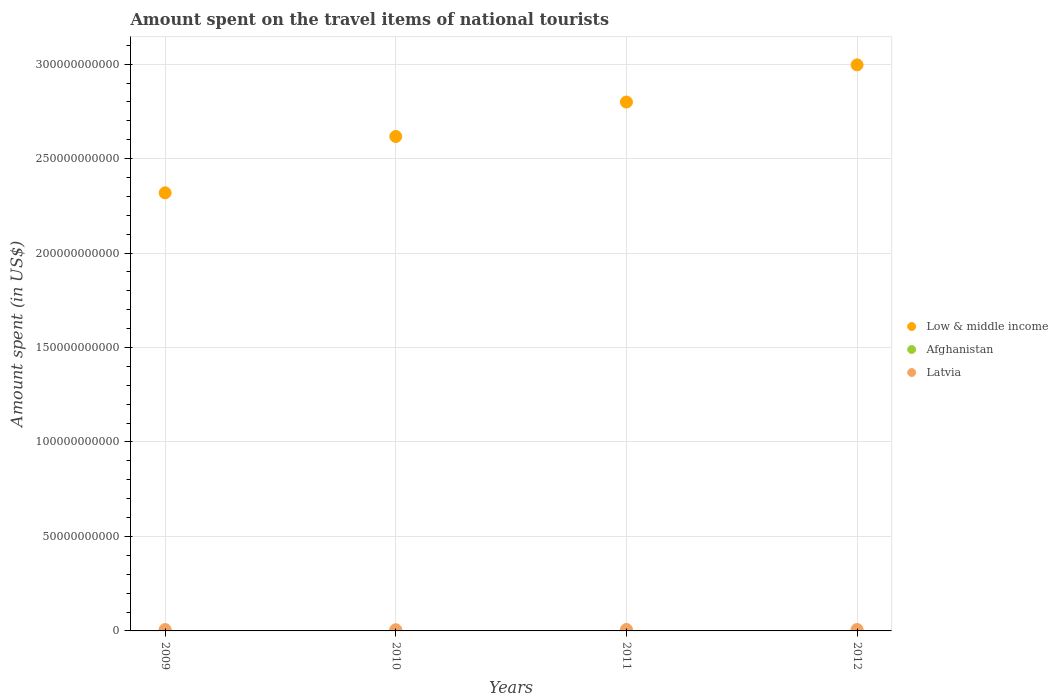Is the number of dotlines equal to the number of legend labels?
Provide a succinct answer. Yes. What is the amount spent on the travel items of national tourists in Low & middle income in 2009?
Your answer should be compact. 2.32e+11. Across all years, what is the maximum amount spent on the travel items of national tourists in Afghanistan?
Offer a terse response. 7.10e+07. Across all years, what is the minimum amount spent on the travel items of national tourists in Afghanistan?
Your answer should be very brief. 3.90e+07. In which year was the amount spent on the travel items of national tourists in Afghanistan maximum?
Make the answer very short. 2011. In which year was the amount spent on the travel items of national tourists in Low & middle income minimum?
Make the answer very short. 2009. What is the total amount spent on the travel items of national tourists in Latvia in the graph?
Ensure brevity in your answer.  2.88e+09. What is the difference between the amount spent on the travel items of national tourists in Afghanistan in 2009 and that in 2010?
Give a very brief answer. -1.60e+07. What is the difference between the amount spent on the travel items of national tourists in Latvia in 2009 and the amount spent on the travel items of national tourists in Afghanistan in 2010?
Your response must be concise. 6.68e+08. What is the average amount spent on the travel items of national tourists in Latvia per year?
Your response must be concise. 7.20e+08. In the year 2011, what is the difference between the amount spent on the travel items of national tourists in Low & middle income and amount spent on the travel items of national tourists in Afghanistan?
Keep it short and to the point. 2.80e+11. What is the ratio of the amount spent on the travel items of national tourists in Low & middle income in 2011 to that in 2012?
Your answer should be compact. 0.93. Is the amount spent on the travel items of national tourists in Latvia in 2010 less than that in 2011?
Your answer should be very brief. Yes. Is the difference between the amount spent on the travel items of national tourists in Low & middle income in 2009 and 2012 greater than the difference between the amount spent on the travel items of national tourists in Afghanistan in 2009 and 2012?
Offer a terse response. No. What is the difference between the highest and the second highest amount spent on the travel items of national tourists in Afghanistan?
Provide a short and direct response. 1.50e+07. What is the difference between the highest and the lowest amount spent on the travel items of national tourists in Afghanistan?
Make the answer very short. 3.20e+07. Is the sum of the amount spent on the travel items of national tourists in Low & middle income in 2009 and 2012 greater than the maximum amount spent on the travel items of national tourists in Afghanistan across all years?
Provide a short and direct response. Yes. Is it the case that in every year, the sum of the amount spent on the travel items of national tourists in Low & middle income and amount spent on the travel items of national tourists in Latvia  is greater than the amount spent on the travel items of national tourists in Afghanistan?
Provide a short and direct response. Yes. Does the amount spent on the travel items of national tourists in Latvia monotonically increase over the years?
Ensure brevity in your answer.  No. Is the amount spent on the travel items of national tourists in Low & middle income strictly greater than the amount spent on the travel items of national tourists in Afghanistan over the years?
Provide a short and direct response. Yes. Is the amount spent on the travel items of national tourists in Afghanistan strictly less than the amount spent on the travel items of national tourists in Low & middle income over the years?
Provide a succinct answer. Yes. What is the difference between two consecutive major ticks on the Y-axis?
Provide a short and direct response. 5.00e+1. Are the values on the major ticks of Y-axis written in scientific E-notation?
Provide a succinct answer. No. Does the graph contain any zero values?
Offer a terse response. No. Where does the legend appear in the graph?
Provide a succinct answer. Center right. How are the legend labels stacked?
Provide a short and direct response. Vertical. What is the title of the graph?
Your answer should be compact. Amount spent on the travel items of national tourists. Does "Israel" appear as one of the legend labels in the graph?
Offer a very short reply. No. What is the label or title of the X-axis?
Your answer should be compact. Years. What is the label or title of the Y-axis?
Your response must be concise. Amount spent (in US$). What is the Amount spent (in US$) in Low & middle income in 2009?
Make the answer very short. 2.32e+11. What is the Amount spent (in US$) of Afghanistan in 2009?
Give a very brief answer. 3.90e+07. What is the Amount spent (in US$) in Latvia in 2009?
Your answer should be compact. 7.23e+08. What is the Amount spent (in US$) of Low & middle income in 2010?
Your response must be concise. 2.62e+11. What is the Amount spent (in US$) in Afghanistan in 2010?
Your answer should be very brief. 5.50e+07. What is the Amount spent (in US$) of Latvia in 2010?
Provide a succinct answer. 6.40e+08. What is the Amount spent (in US$) in Low & middle income in 2011?
Give a very brief answer. 2.80e+11. What is the Amount spent (in US$) in Afghanistan in 2011?
Provide a succinct answer. 7.10e+07. What is the Amount spent (in US$) in Latvia in 2011?
Your answer should be compact. 7.71e+08. What is the Amount spent (in US$) in Low & middle income in 2012?
Your answer should be compact. 3.00e+11. What is the Amount spent (in US$) in Afghanistan in 2012?
Make the answer very short. 5.60e+07. What is the Amount spent (in US$) of Latvia in 2012?
Your response must be concise. 7.45e+08. Across all years, what is the maximum Amount spent (in US$) in Low & middle income?
Provide a short and direct response. 3.00e+11. Across all years, what is the maximum Amount spent (in US$) in Afghanistan?
Ensure brevity in your answer.  7.10e+07. Across all years, what is the maximum Amount spent (in US$) in Latvia?
Ensure brevity in your answer.  7.71e+08. Across all years, what is the minimum Amount spent (in US$) of Low & middle income?
Make the answer very short. 2.32e+11. Across all years, what is the minimum Amount spent (in US$) of Afghanistan?
Offer a very short reply. 3.90e+07. Across all years, what is the minimum Amount spent (in US$) in Latvia?
Your response must be concise. 6.40e+08. What is the total Amount spent (in US$) of Low & middle income in the graph?
Give a very brief answer. 1.07e+12. What is the total Amount spent (in US$) of Afghanistan in the graph?
Your answer should be very brief. 2.21e+08. What is the total Amount spent (in US$) of Latvia in the graph?
Give a very brief answer. 2.88e+09. What is the difference between the Amount spent (in US$) of Low & middle income in 2009 and that in 2010?
Ensure brevity in your answer.  -2.98e+1. What is the difference between the Amount spent (in US$) of Afghanistan in 2009 and that in 2010?
Offer a terse response. -1.60e+07. What is the difference between the Amount spent (in US$) in Latvia in 2009 and that in 2010?
Offer a very short reply. 8.30e+07. What is the difference between the Amount spent (in US$) of Low & middle income in 2009 and that in 2011?
Provide a succinct answer. -4.81e+1. What is the difference between the Amount spent (in US$) of Afghanistan in 2009 and that in 2011?
Make the answer very short. -3.20e+07. What is the difference between the Amount spent (in US$) in Latvia in 2009 and that in 2011?
Provide a short and direct response. -4.80e+07. What is the difference between the Amount spent (in US$) of Low & middle income in 2009 and that in 2012?
Ensure brevity in your answer.  -6.77e+1. What is the difference between the Amount spent (in US$) in Afghanistan in 2009 and that in 2012?
Offer a very short reply. -1.70e+07. What is the difference between the Amount spent (in US$) in Latvia in 2009 and that in 2012?
Keep it short and to the point. -2.20e+07. What is the difference between the Amount spent (in US$) of Low & middle income in 2010 and that in 2011?
Provide a short and direct response. -1.82e+1. What is the difference between the Amount spent (in US$) in Afghanistan in 2010 and that in 2011?
Provide a succinct answer. -1.60e+07. What is the difference between the Amount spent (in US$) of Latvia in 2010 and that in 2011?
Your answer should be compact. -1.31e+08. What is the difference between the Amount spent (in US$) in Low & middle income in 2010 and that in 2012?
Your answer should be compact. -3.79e+1. What is the difference between the Amount spent (in US$) in Latvia in 2010 and that in 2012?
Give a very brief answer. -1.05e+08. What is the difference between the Amount spent (in US$) in Low & middle income in 2011 and that in 2012?
Keep it short and to the point. -1.97e+1. What is the difference between the Amount spent (in US$) of Afghanistan in 2011 and that in 2012?
Your answer should be very brief. 1.50e+07. What is the difference between the Amount spent (in US$) in Latvia in 2011 and that in 2012?
Your response must be concise. 2.60e+07. What is the difference between the Amount spent (in US$) in Low & middle income in 2009 and the Amount spent (in US$) in Afghanistan in 2010?
Give a very brief answer. 2.32e+11. What is the difference between the Amount spent (in US$) in Low & middle income in 2009 and the Amount spent (in US$) in Latvia in 2010?
Your response must be concise. 2.31e+11. What is the difference between the Amount spent (in US$) in Afghanistan in 2009 and the Amount spent (in US$) in Latvia in 2010?
Give a very brief answer. -6.01e+08. What is the difference between the Amount spent (in US$) of Low & middle income in 2009 and the Amount spent (in US$) of Afghanistan in 2011?
Your answer should be compact. 2.32e+11. What is the difference between the Amount spent (in US$) in Low & middle income in 2009 and the Amount spent (in US$) in Latvia in 2011?
Offer a very short reply. 2.31e+11. What is the difference between the Amount spent (in US$) in Afghanistan in 2009 and the Amount spent (in US$) in Latvia in 2011?
Offer a terse response. -7.32e+08. What is the difference between the Amount spent (in US$) in Low & middle income in 2009 and the Amount spent (in US$) in Afghanistan in 2012?
Offer a terse response. 2.32e+11. What is the difference between the Amount spent (in US$) of Low & middle income in 2009 and the Amount spent (in US$) of Latvia in 2012?
Give a very brief answer. 2.31e+11. What is the difference between the Amount spent (in US$) of Afghanistan in 2009 and the Amount spent (in US$) of Latvia in 2012?
Provide a succinct answer. -7.06e+08. What is the difference between the Amount spent (in US$) of Low & middle income in 2010 and the Amount spent (in US$) of Afghanistan in 2011?
Keep it short and to the point. 2.62e+11. What is the difference between the Amount spent (in US$) of Low & middle income in 2010 and the Amount spent (in US$) of Latvia in 2011?
Your answer should be compact. 2.61e+11. What is the difference between the Amount spent (in US$) in Afghanistan in 2010 and the Amount spent (in US$) in Latvia in 2011?
Your response must be concise. -7.16e+08. What is the difference between the Amount spent (in US$) of Low & middle income in 2010 and the Amount spent (in US$) of Afghanistan in 2012?
Your answer should be compact. 2.62e+11. What is the difference between the Amount spent (in US$) in Low & middle income in 2010 and the Amount spent (in US$) in Latvia in 2012?
Keep it short and to the point. 2.61e+11. What is the difference between the Amount spent (in US$) of Afghanistan in 2010 and the Amount spent (in US$) of Latvia in 2012?
Provide a succinct answer. -6.90e+08. What is the difference between the Amount spent (in US$) of Low & middle income in 2011 and the Amount spent (in US$) of Afghanistan in 2012?
Your answer should be compact. 2.80e+11. What is the difference between the Amount spent (in US$) of Low & middle income in 2011 and the Amount spent (in US$) of Latvia in 2012?
Offer a terse response. 2.79e+11. What is the difference between the Amount spent (in US$) of Afghanistan in 2011 and the Amount spent (in US$) of Latvia in 2012?
Provide a succinct answer. -6.74e+08. What is the average Amount spent (in US$) of Low & middle income per year?
Provide a short and direct response. 2.68e+11. What is the average Amount spent (in US$) of Afghanistan per year?
Your answer should be very brief. 5.52e+07. What is the average Amount spent (in US$) of Latvia per year?
Provide a succinct answer. 7.20e+08. In the year 2009, what is the difference between the Amount spent (in US$) of Low & middle income and Amount spent (in US$) of Afghanistan?
Offer a terse response. 2.32e+11. In the year 2009, what is the difference between the Amount spent (in US$) in Low & middle income and Amount spent (in US$) in Latvia?
Your answer should be very brief. 2.31e+11. In the year 2009, what is the difference between the Amount spent (in US$) in Afghanistan and Amount spent (in US$) in Latvia?
Make the answer very short. -6.84e+08. In the year 2010, what is the difference between the Amount spent (in US$) of Low & middle income and Amount spent (in US$) of Afghanistan?
Make the answer very short. 2.62e+11. In the year 2010, what is the difference between the Amount spent (in US$) of Low & middle income and Amount spent (in US$) of Latvia?
Offer a very short reply. 2.61e+11. In the year 2010, what is the difference between the Amount spent (in US$) in Afghanistan and Amount spent (in US$) in Latvia?
Your answer should be compact. -5.85e+08. In the year 2011, what is the difference between the Amount spent (in US$) of Low & middle income and Amount spent (in US$) of Afghanistan?
Keep it short and to the point. 2.80e+11. In the year 2011, what is the difference between the Amount spent (in US$) of Low & middle income and Amount spent (in US$) of Latvia?
Ensure brevity in your answer.  2.79e+11. In the year 2011, what is the difference between the Amount spent (in US$) in Afghanistan and Amount spent (in US$) in Latvia?
Provide a succinct answer. -7.00e+08. In the year 2012, what is the difference between the Amount spent (in US$) of Low & middle income and Amount spent (in US$) of Afghanistan?
Provide a succinct answer. 3.00e+11. In the year 2012, what is the difference between the Amount spent (in US$) in Low & middle income and Amount spent (in US$) in Latvia?
Ensure brevity in your answer.  2.99e+11. In the year 2012, what is the difference between the Amount spent (in US$) of Afghanistan and Amount spent (in US$) of Latvia?
Keep it short and to the point. -6.89e+08. What is the ratio of the Amount spent (in US$) of Low & middle income in 2009 to that in 2010?
Your response must be concise. 0.89. What is the ratio of the Amount spent (in US$) in Afghanistan in 2009 to that in 2010?
Your answer should be compact. 0.71. What is the ratio of the Amount spent (in US$) in Latvia in 2009 to that in 2010?
Offer a very short reply. 1.13. What is the ratio of the Amount spent (in US$) in Low & middle income in 2009 to that in 2011?
Make the answer very short. 0.83. What is the ratio of the Amount spent (in US$) in Afghanistan in 2009 to that in 2011?
Your answer should be compact. 0.55. What is the ratio of the Amount spent (in US$) of Latvia in 2009 to that in 2011?
Your answer should be compact. 0.94. What is the ratio of the Amount spent (in US$) in Low & middle income in 2009 to that in 2012?
Make the answer very short. 0.77. What is the ratio of the Amount spent (in US$) of Afghanistan in 2009 to that in 2012?
Offer a terse response. 0.7. What is the ratio of the Amount spent (in US$) in Latvia in 2009 to that in 2012?
Your answer should be very brief. 0.97. What is the ratio of the Amount spent (in US$) in Low & middle income in 2010 to that in 2011?
Provide a short and direct response. 0.93. What is the ratio of the Amount spent (in US$) of Afghanistan in 2010 to that in 2011?
Your answer should be very brief. 0.77. What is the ratio of the Amount spent (in US$) in Latvia in 2010 to that in 2011?
Make the answer very short. 0.83. What is the ratio of the Amount spent (in US$) in Low & middle income in 2010 to that in 2012?
Offer a very short reply. 0.87. What is the ratio of the Amount spent (in US$) of Afghanistan in 2010 to that in 2012?
Provide a succinct answer. 0.98. What is the ratio of the Amount spent (in US$) of Latvia in 2010 to that in 2012?
Offer a very short reply. 0.86. What is the ratio of the Amount spent (in US$) of Low & middle income in 2011 to that in 2012?
Provide a short and direct response. 0.93. What is the ratio of the Amount spent (in US$) of Afghanistan in 2011 to that in 2012?
Provide a short and direct response. 1.27. What is the ratio of the Amount spent (in US$) in Latvia in 2011 to that in 2012?
Make the answer very short. 1.03. What is the difference between the highest and the second highest Amount spent (in US$) of Low & middle income?
Your response must be concise. 1.97e+1. What is the difference between the highest and the second highest Amount spent (in US$) of Afghanistan?
Keep it short and to the point. 1.50e+07. What is the difference between the highest and the second highest Amount spent (in US$) in Latvia?
Keep it short and to the point. 2.60e+07. What is the difference between the highest and the lowest Amount spent (in US$) in Low & middle income?
Your response must be concise. 6.77e+1. What is the difference between the highest and the lowest Amount spent (in US$) of Afghanistan?
Your response must be concise. 3.20e+07. What is the difference between the highest and the lowest Amount spent (in US$) in Latvia?
Offer a very short reply. 1.31e+08. 